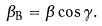Convert formula to latex. <formula><loc_0><loc_0><loc_500><loc_500>\beta _ { \text {B} } = \beta \cos \gamma .</formula> 